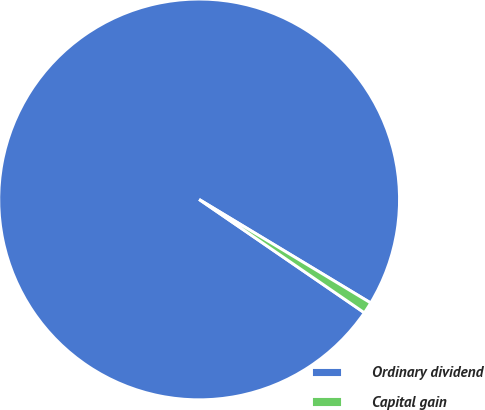Convert chart. <chart><loc_0><loc_0><loc_500><loc_500><pie_chart><fcel>Ordinary dividend<fcel>Capital gain<nl><fcel>99.07%<fcel>0.93%<nl></chart> 